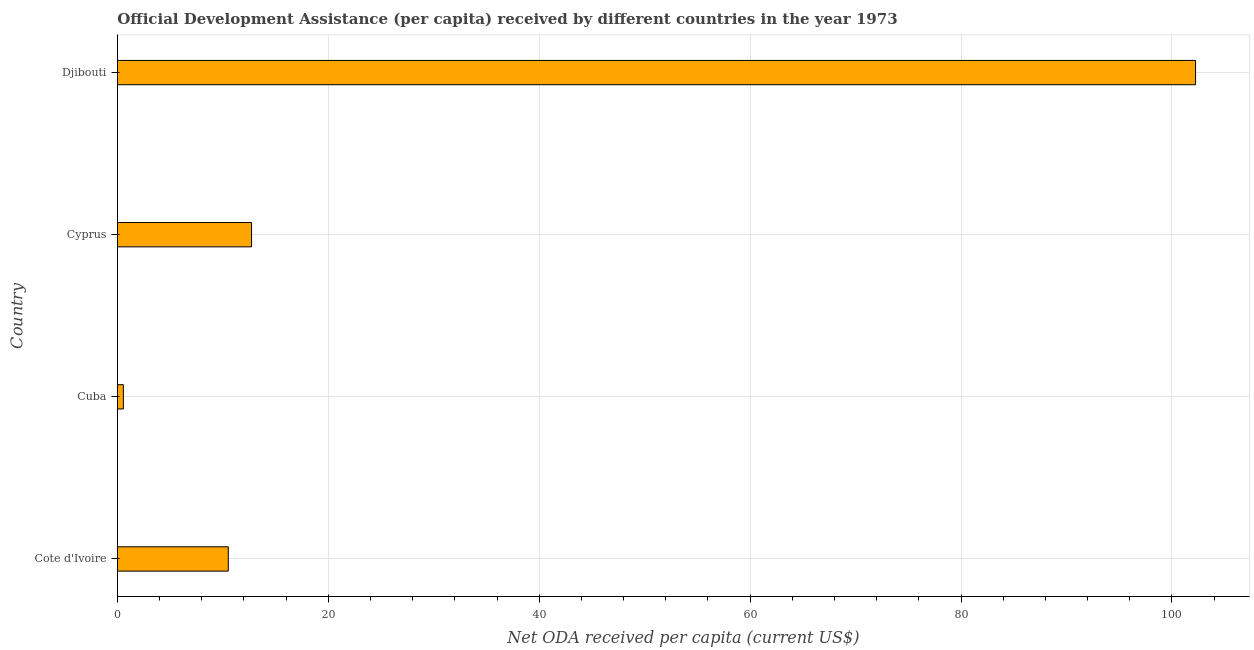What is the title of the graph?
Your answer should be compact. Official Development Assistance (per capita) received by different countries in the year 1973. What is the label or title of the X-axis?
Give a very brief answer. Net ODA received per capita (current US$). What is the net oda received per capita in Cuba?
Make the answer very short. 0.57. Across all countries, what is the maximum net oda received per capita?
Offer a very short reply. 102.24. Across all countries, what is the minimum net oda received per capita?
Ensure brevity in your answer.  0.57. In which country was the net oda received per capita maximum?
Make the answer very short. Djibouti. In which country was the net oda received per capita minimum?
Ensure brevity in your answer.  Cuba. What is the sum of the net oda received per capita?
Give a very brief answer. 126.04. What is the difference between the net oda received per capita in Cuba and Cyprus?
Your response must be concise. -12.16. What is the average net oda received per capita per country?
Give a very brief answer. 31.51. What is the median net oda received per capita?
Make the answer very short. 11.62. What is the ratio of the net oda received per capita in Cuba to that in Cyprus?
Offer a terse response. 0.04. Is the difference between the net oda received per capita in Cote d'Ivoire and Cyprus greater than the difference between any two countries?
Your response must be concise. No. What is the difference between the highest and the second highest net oda received per capita?
Offer a terse response. 89.52. Is the sum of the net oda received per capita in Cote d'Ivoire and Djibouti greater than the maximum net oda received per capita across all countries?
Give a very brief answer. Yes. What is the difference between the highest and the lowest net oda received per capita?
Your answer should be very brief. 101.67. In how many countries, is the net oda received per capita greater than the average net oda received per capita taken over all countries?
Provide a short and direct response. 1. How many countries are there in the graph?
Give a very brief answer. 4. What is the difference between two consecutive major ticks on the X-axis?
Offer a very short reply. 20. What is the Net ODA received per capita (current US$) of Cote d'Ivoire?
Provide a short and direct response. 10.52. What is the Net ODA received per capita (current US$) in Cuba?
Ensure brevity in your answer.  0.57. What is the Net ODA received per capita (current US$) in Cyprus?
Offer a very short reply. 12.72. What is the Net ODA received per capita (current US$) in Djibouti?
Provide a short and direct response. 102.24. What is the difference between the Net ODA received per capita (current US$) in Cote d'Ivoire and Cuba?
Make the answer very short. 9.95. What is the difference between the Net ODA received per capita (current US$) in Cote d'Ivoire and Cyprus?
Give a very brief answer. -2.21. What is the difference between the Net ODA received per capita (current US$) in Cote d'Ivoire and Djibouti?
Your answer should be very brief. -91.72. What is the difference between the Net ODA received per capita (current US$) in Cuba and Cyprus?
Keep it short and to the point. -12.16. What is the difference between the Net ODA received per capita (current US$) in Cuba and Djibouti?
Provide a short and direct response. -101.67. What is the difference between the Net ODA received per capita (current US$) in Cyprus and Djibouti?
Provide a succinct answer. -89.52. What is the ratio of the Net ODA received per capita (current US$) in Cote d'Ivoire to that in Cuba?
Ensure brevity in your answer.  18.59. What is the ratio of the Net ODA received per capita (current US$) in Cote d'Ivoire to that in Cyprus?
Your answer should be very brief. 0.83. What is the ratio of the Net ODA received per capita (current US$) in Cote d'Ivoire to that in Djibouti?
Your answer should be very brief. 0.1. What is the ratio of the Net ODA received per capita (current US$) in Cuba to that in Cyprus?
Your answer should be compact. 0.04. What is the ratio of the Net ODA received per capita (current US$) in Cuba to that in Djibouti?
Offer a terse response. 0.01. What is the ratio of the Net ODA received per capita (current US$) in Cyprus to that in Djibouti?
Keep it short and to the point. 0.12. 